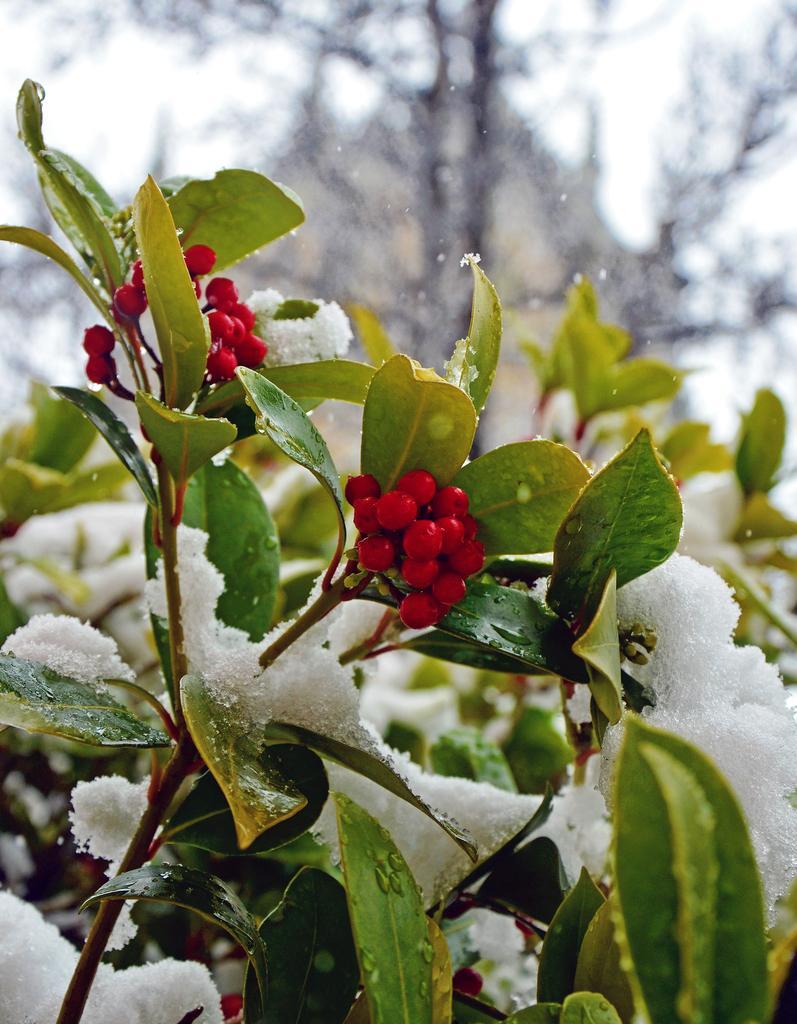Can you describe this image briefly? In this image there are fruits of a plant and it is covered with snow. 